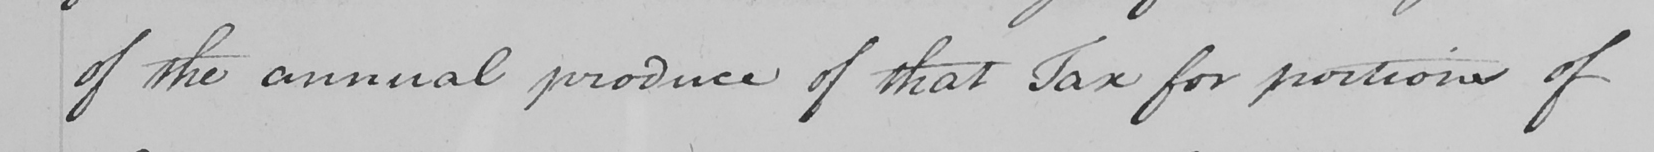Can you tell me what this handwritten text says? of the annual produce of that Tax for the portions of 